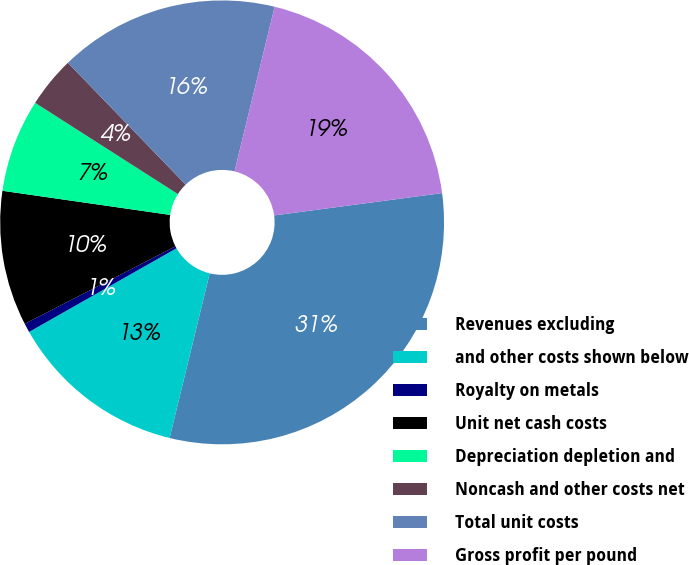<chart> <loc_0><loc_0><loc_500><loc_500><pie_chart><fcel>Revenues excluding<fcel>and other costs shown below<fcel>Royalty on metals<fcel>Unit net cash costs<fcel>Depreciation depletion and<fcel>Noncash and other costs net<fcel>Total unit costs<fcel>Gross profit per pound<nl><fcel>30.91%<fcel>12.98%<fcel>0.66%<fcel>9.83%<fcel>6.78%<fcel>3.72%<fcel>16.03%<fcel>19.09%<nl></chart> 